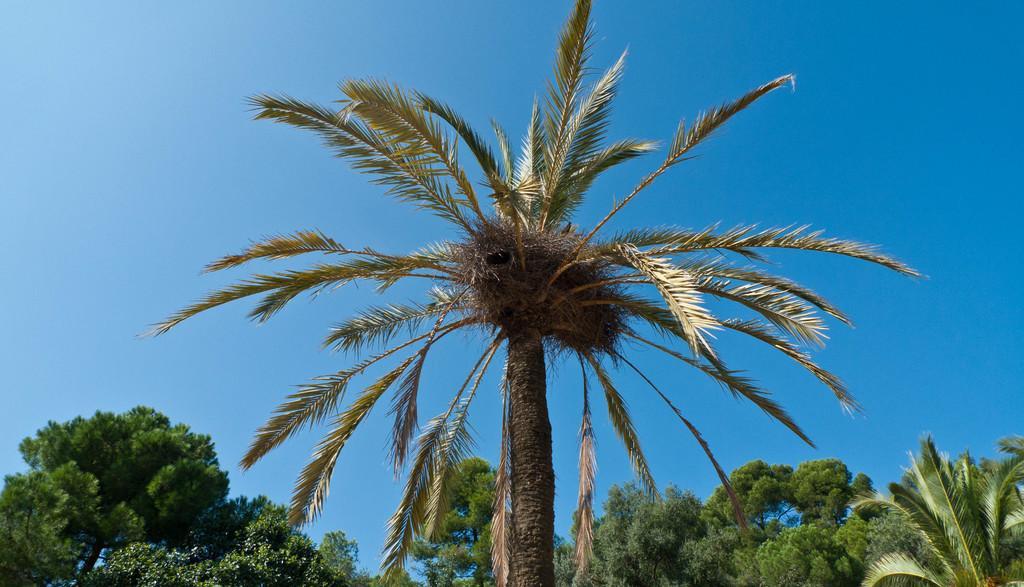Can you describe this image briefly? We can trees and sky in blue color. 